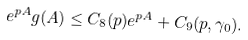<formula> <loc_0><loc_0><loc_500><loc_500>e ^ { p A } g ( A ) \leq C _ { 8 } ( p ) e ^ { p A } + C _ { 9 } ( p , \gamma _ { 0 } ) .</formula> 